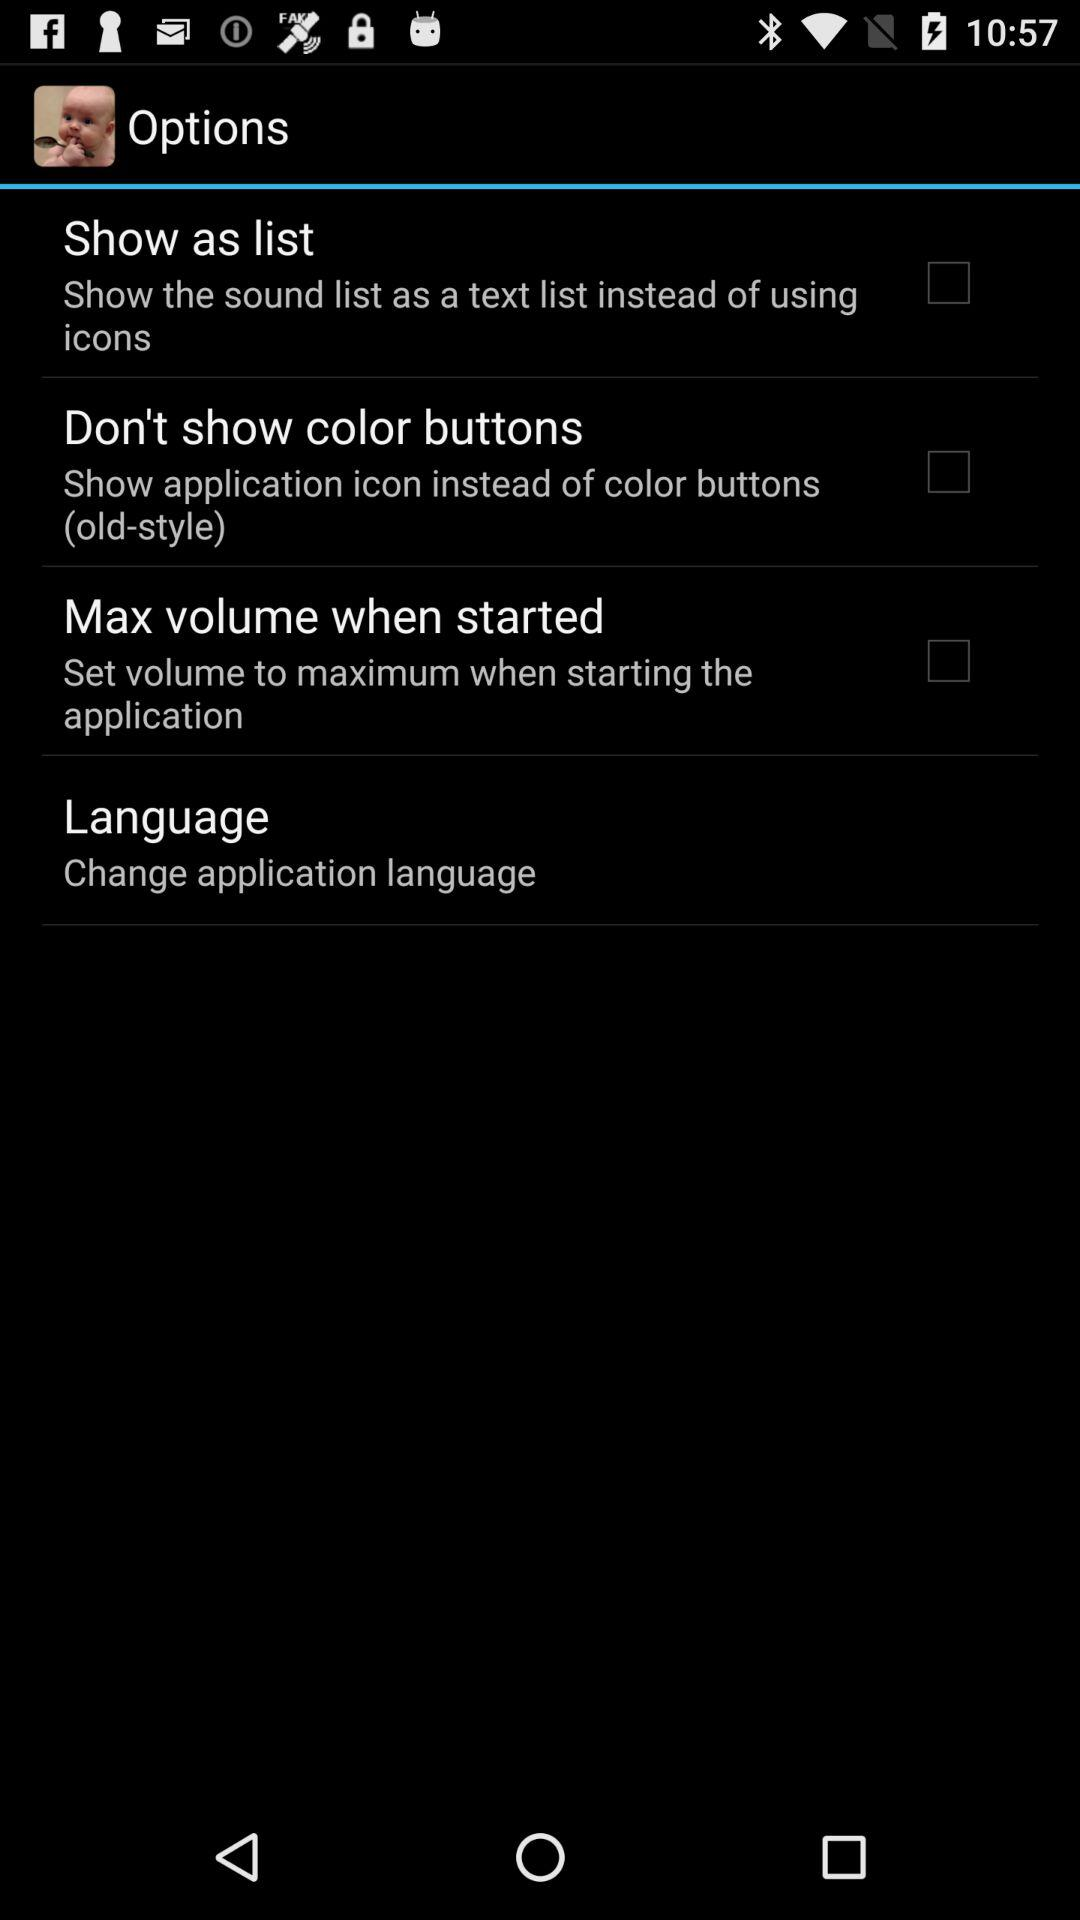Which language is chosen for the application?
When the provided information is insufficient, respond with <no answer>. <no answer> 